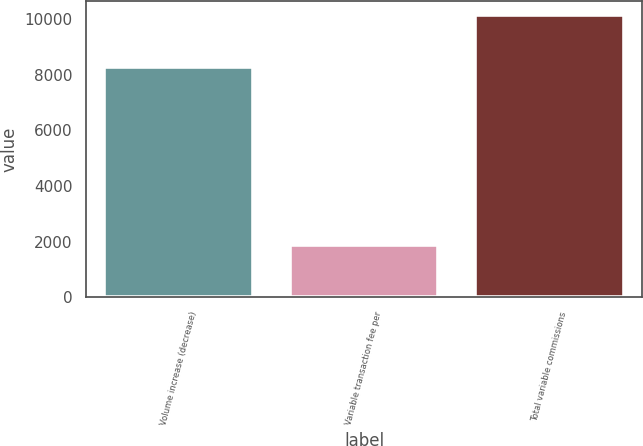<chart> <loc_0><loc_0><loc_500><loc_500><bar_chart><fcel>Volume increase (decrease)<fcel>Variable transaction fee per<fcel>Total variable commissions<nl><fcel>8261<fcel>1869<fcel>10130<nl></chart> 